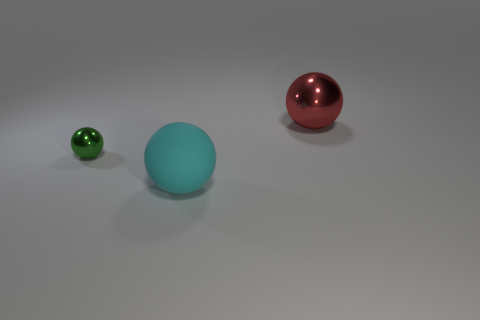What number of things are either objects on the left side of the cyan object or brown rubber balls?
Provide a succinct answer. 1. What size is the metallic thing that is in front of the big sphere on the right side of the large sphere that is in front of the big red metallic ball?
Keep it short and to the point. Small. Is there any other thing that has the same shape as the green object?
Make the answer very short. Yes. There is a metallic thing that is left of the sphere that is to the right of the rubber sphere; what is its size?
Your answer should be very brief. Small. What number of small things are either gray metallic cylinders or green metallic objects?
Make the answer very short. 1. Is the number of small green metal objects less than the number of metallic spheres?
Offer a very short reply. Yes. Are there any other things that are the same size as the red metal thing?
Offer a terse response. Yes. Do the small metal ball and the rubber ball have the same color?
Give a very brief answer. No. Is the number of small cyan rubber cylinders greater than the number of big rubber objects?
Keep it short and to the point. No. How many other things are there of the same color as the tiny metal sphere?
Make the answer very short. 0. 